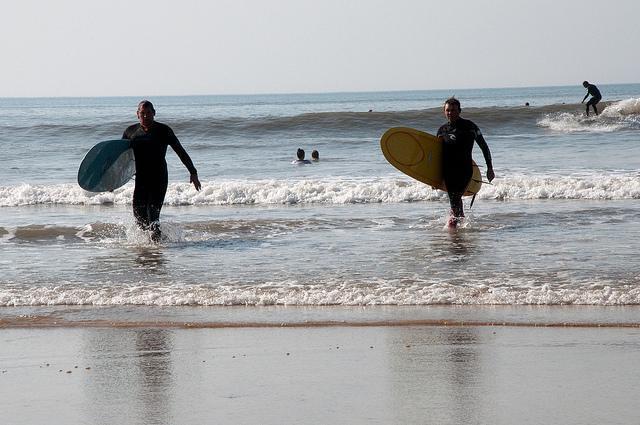What color is the surfboard held by the man walking up the beach on the right?
Select the accurate answer and provide explanation: 'Answer: answer
Rationale: rationale.'
Options: Yellow, blue, white, orange. Answer: yellow.
Rationale: It's the color of a banana 